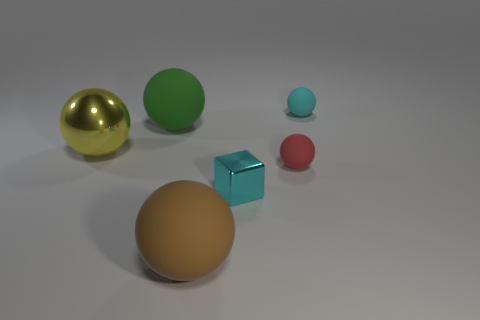Subtract 2 spheres. How many spheres are left? 3 Subtract all brown spheres. How many spheres are left? 4 Subtract all cyan spheres. How many spheres are left? 4 Subtract all purple balls. Subtract all red cubes. How many balls are left? 5 Add 3 yellow matte balls. How many objects exist? 9 Subtract all balls. How many objects are left? 1 Add 3 big rubber balls. How many big rubber balls are left? 5 Add 5 yellow spheres. How many yellow spheres exist? 6 Subtract 0 brown blocks. How many objects are left? 6 Subtract all cyan rubber cylinders. Subtract all large green balls. How many objects are left? 5 